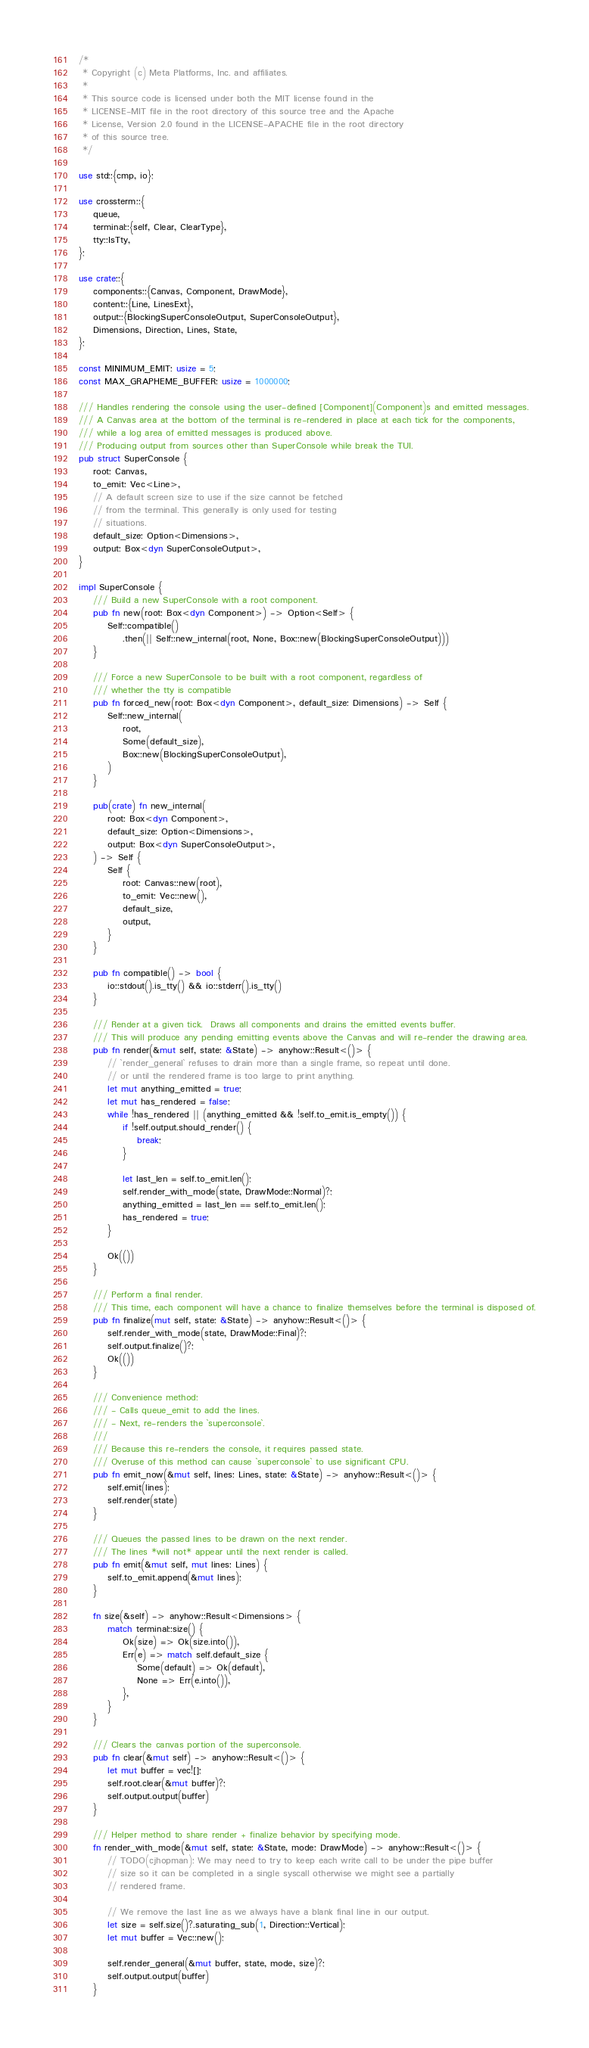Convert code to text. <code><loc_0><loc_0><loc_500><loc_500><_Rust_>/*
 * Copyright (c) Meta Platforms, Inc. and affiliates.
 *
 * This source code is licensed under both the MIT license found in the
 * LICENSE-MIT file in the root directory of this source tree and the Apache
 * License, Version 2.0 found in the LICENSE-APACHE file in the root directory
 * of this source tree.
 */

use std::{cmp, io};

use crossterm::{
    queue,
    terminal::{self, Clear, ClearType},
    tty::IsTty,
};

use crate::{
    components::{Canvas, Component, DrawMode},
    content::{Line, LinesExt},
    output::{BlockingSuperConsoleOutput, SuperConsoleOutput},
    Dimensions, Direction, Lines, State,
};

const MINIMUM_EMIT: usize = 5;
const MAX_GRAPHEME_BUFFER: usize = 1000000;

/// Handles rendering the console using the user-defined [Component](Component)s and emitted messages.
/// A Canvas area at the bottom of the terminal is re-rendered in place at each tick for the components,
/// while a log area of emitted messages is produced above.
/// Producing output from sources other than SuperConsole while break the TUI.
pub struct SuperConsole {
    root: Canvas,
    to_emit: Vec<Line>,
    // A default screen size to use if the size cannot be fetched
    // from the terminal. This generally is only used for testing
    // situations.
    default_size: Option<Dimensions>,
    output: Box<dyn SuperConsoleOutput>,
}

impl SuperConsole {
    /// Build a new SuperConsole with a root component.
    pub fn new(root: Box<dyn Component>) -> Option<Self> {
        Self::compatible()
            .then(|| Self::new_internal(root, None, Box::new(BlockingSuperConsoleOutput)))
    }

    /// Force a new SuperConsole to be built with a root component, regardless of
    /// whether the tty is compatible
    pub fn forced_new(root: Box<dyn Component>, default_size: Dimensions) -> Self {
        Self::new_internal(
            root,
            Some(default_size),
            Box::new(BlockingSuperConsoleOutput),
        )
    }

    pub(crate) fn new_internal(
        root: Box<dyn Component>,
        default_size: Option<Dimensions>,
        output: Box<dyn SuperConsoleOutput>,
    ) -> Self {
        Self {
            root: Canvas::new(root),
            to_emit: Vec::new(),
            default_size,
            output,
        }
    }

    pub fn compatible() -> bool {
        io::stdout().is_tty() && io::stderr().is_tty()
    }

    /// Render at a given tick.  Draws all components and drains the emitted events buffer.
    /// This will produce any pending emitting events above the Canvas and will re-render the drawing area.
    pub fn render(&mut self, state: &State) -> anyhow::Result<()> {
        // `render_general` refuses to drain more than a single frame, so repeat until done.
        // or until the rendered frame is too large to print anything.
        let mut anything_emitted = true;
        let mut has_rendered = false;
        while !has_rendered || (anything_emitted && !self.to_emit.is_empty()) {
            if !self.output.should_render() {
                break;
            }

            let last_len = self.to_emit.len();
            self.render_with_mode(state, DrawMode::Normal)?;
            anything_emitted = last_len == self.to_emit.len();
            has_rendered = true;
        }

        Ok(())
    }

    /// Perform a final render.
    /// This time, each component will have a chance to finalize themselves before the terminal is disposed of.
    pub fn finalize(mut self, state: &State) -> anyhow::Result<()> {
        self.render_with_mode(state, DrawMode::Final)?;
        self.output.finalize()?;
        Ok(())
    }

    /// Convenience method:
    /// - Calls queue_emit to add the lines.
    /// - Next, re-renders the `superconsole`.
    ///
    /// Because this re-renders the console, it requires passed state.
    /// Overuse of this method can cause `superconsole` to use significant CPU.
    pub fn emit_now(&mut self, lines: Lines, state: &State) -> anyhow::Result<()> {
        self.emit(lines);
        self.render(state)
    }

    /// Queues the passed lines to be drawn on the next render.
    /// The lines *will not* appear until the next render is called.
    pub fn emit(&mut self, mut lines: Lines) {
        self.to_emit.append(&mut lines);
    }

    fn size(&self) -> anyhow::Result<Dimensions> {
        match terminal::size() {
            Ok(size) => Ok(size.into()),
            Err(e) => match self.default_size {
                Some(default) => Ok(default),
                None => Err(e.into()),
            },
        }
    }

    /// Clears the canvas portion of the superconsole.
    pub fn clear(&mut self) -> anyhow::Result<()> {
        let mut buffer = vec![];
        self.root.clear(&mut buffer)?;
        self.output.output(buffer)
    }

    /// Helper method to share render + finalize behavior by specifying mode.
    fn render_with_mode(&mut self, state: &State, mode: DrawMode) -> anyhow::Result<()> {
        // TODO(cjhopman): We may need to try to keep each write call to be under the pipe buffer
        // size so it can be completed in a single syscall otherwise we might see a partially
        // rendered frame.

        // We remove the last line as we always have a blank final line in our output.
        let size = self.size()?.saturating_sub(1, Direction::Vertical);
        let mut buffer = Vec::new();

        self.render_general(&mut buffer, state, mode, size)?;
        self.output.output(buffer)
    }
</code> 